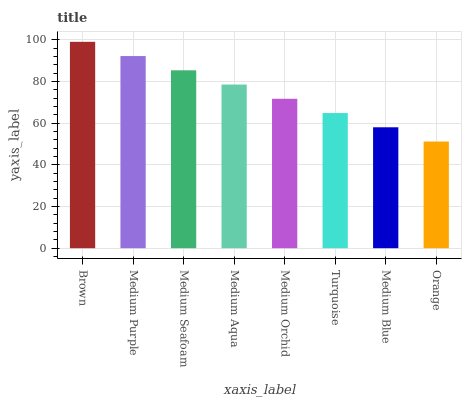Is Orange the minimum?
Answer yes or no. Yes. Is Brown the maximum?
Answer yes or no. Yes. Is Medium Purple the minimum?
Answer yes or no. No. Is Medium Purple the maximum?
Answer yes or no. No. Is Brown greater than Medium Purple?
Answer yes or no. Yes. Is Medium Purple less than Brown?
Answer yes or no. Yes. Is Medium Purple greater than Brown?
Answer yes or no. No. Is Brown less than Medium Purple?
Answer yes or no. No. Is Medium Aqua the high median?
Answer yes or no. Yes. Is Medium Orchid the low median?
Answer yes or no. Yes. Is Brown the high median?
Answer yes or no. No. Is Turquoise the low median?
Answer yes or no. No. 